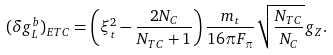Convert formula to latex. <formula><loc_0><loc_0><loc_500><loc_500>( \delta g _ { L } ^ { b } ) _ { E T C } = \left ( \xi _ { t } ^ { 2 } - { \frac { 2 N _ { C } } { N _ { T C } + 1 } } \right ) { \frac { m _ { t } } { 1 6 \pi F _ { \pi } } } \sqrt { { \frac { N _ { T C } } { N _ { C } } } } g _ { Z } .</formula> 